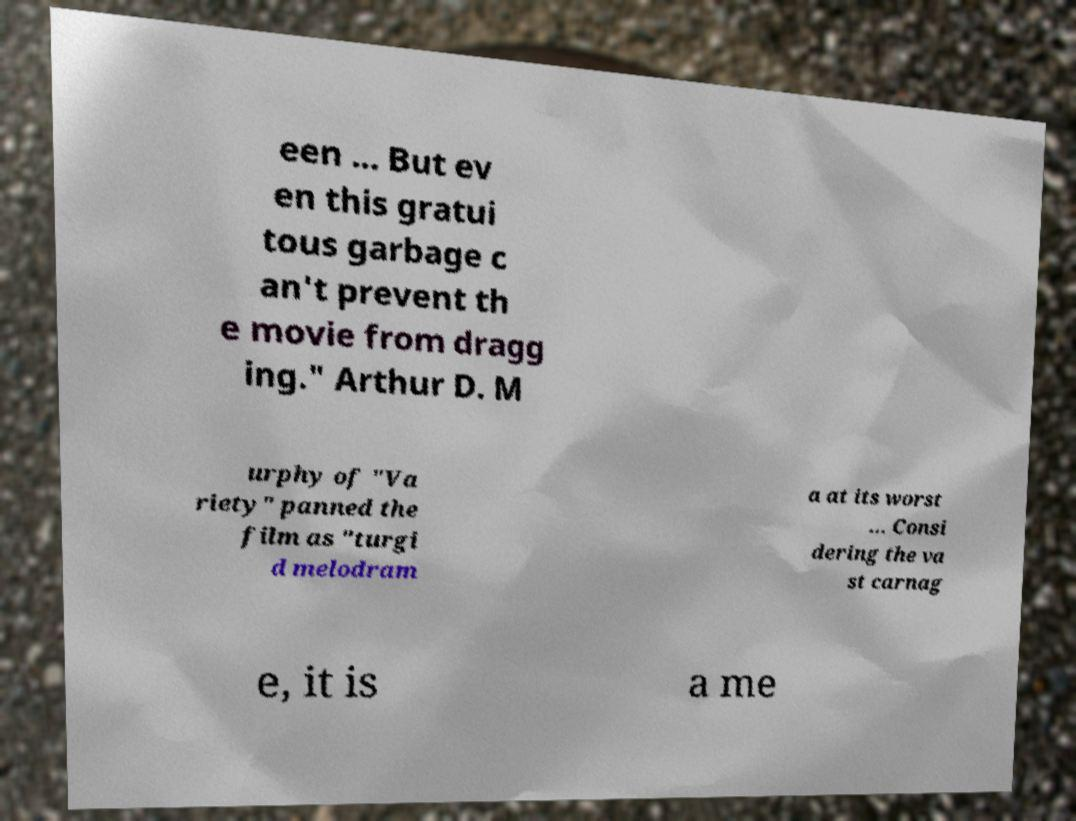I need the written content from this picture converted into text. Can you do that? een ... But ev en this gratui tous garbage c an't prevent th e movie from dragg ing." Arthur D. M urphy of "Va riety" panned the film as "turgi d melodram a at its worst ... Consi dering the va st carnag e, it is a me 